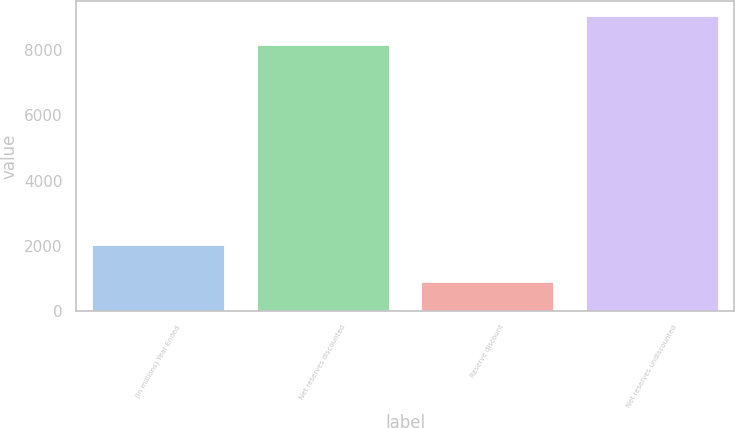<chart> <loc_0><loc_0><loc_500><loc_500><bar_chart><fcel>(In millions) Year Ended<fcel>Net reserves discounted<fcel>Reserve discount<fcel>Net reserves undiscounted<nl><fcel>2011<fcel>8172<fcel>892<fcel>9064<nl></chart> 